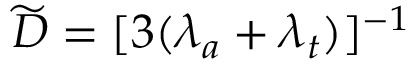Convert formula to latex. <formula><loc_0><loc_0><loc_500><loc_500>\widetilde { D } = [ 3 ( \lambda _ { a } + \lambda _ { t } ) ] ^ { - 1 }</formula> 